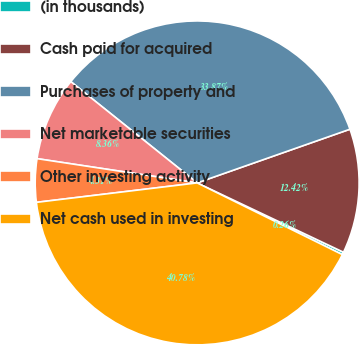Convert chart to OTSL. <chart><loc_0><loc_0><loc_500><loc_500><pie_chart><fcel>(in thousands)<fcel>Cash paid for acquired<fcel>Purchases of property and<fcel>Net marketable securities<fcel>Other investing activity<fcel>Net cash used in investing<nl><fcel>0.26%<fcel>12.42%<fcel>33.87%<fcel>8.36%<fcel>4.31%<fcel>40.78%<nl></chart> 